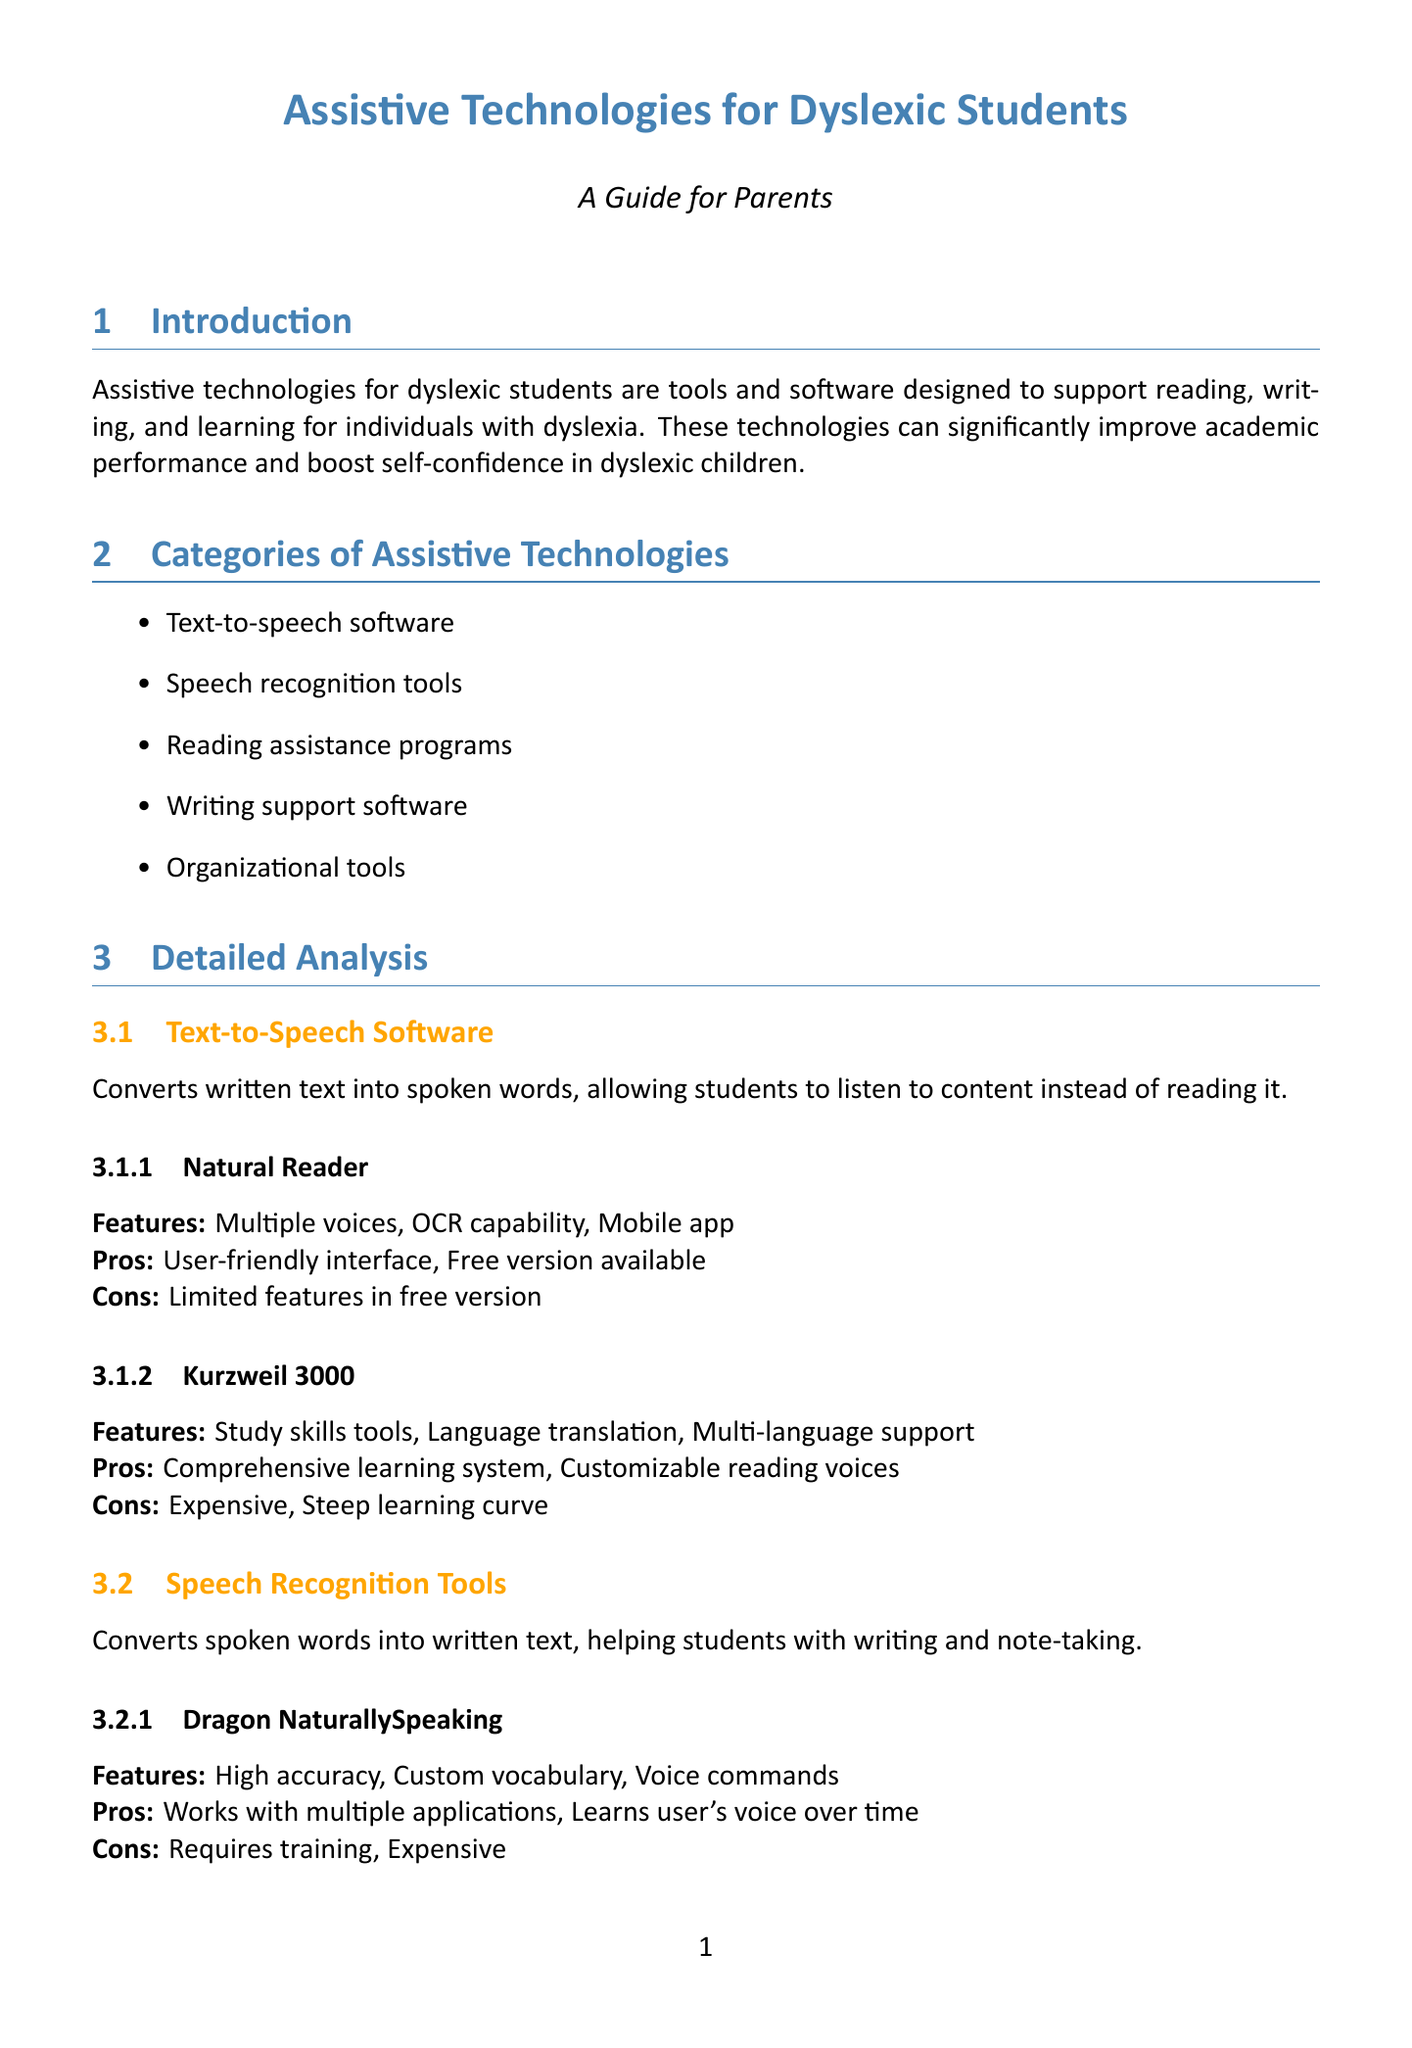what are the categories of assistive technologies? The document lists five categories, which include Text-to-speech software, Speech recognition tools, Reading assistance programs, Writing support software, and Organizational tools.
Answer: Text-to-speech software, Speech recognition tools, Reading assistance programs, Writing support software, Organizational tools what is the main purpose of text-to-speech software? The main purpose is to convert written text into spoken words, allowing students to listen to content instead of reading it.
Answer: Convert written text into spoken words name one example of reading assistance programs. The document mentions two examples, but one is Readability.
Answer: Readability what is an advantage of using Grammarly? One advantage noted in the document is that it works across multiple platforms and provides real-time suggestions.
Answer: Works across multiple platforms how should parents begin implementing assistive technologies? According to the document, parents should start with one or two tools to avoid overwhelming the child.
Answer: Start with one or two tools what are two considerations for parents when choosing assistive technologies? The document lists several factors, two of which are the child's specific needs and the age-appropriateness of the technology.
Answer: Child's specific needs, Age-appropriateness of the technology which tool has high accuracy and custom vocabulary? The tool mentioned in the document with these features is Dragon NaturallySpeaking.
Answer: Dragon NaturallySpeaking what do Beeline Reader's features help reduce? According to the document, Beeline Reader's features help reduce eye fatigue.
Answer: Eye fatigue 